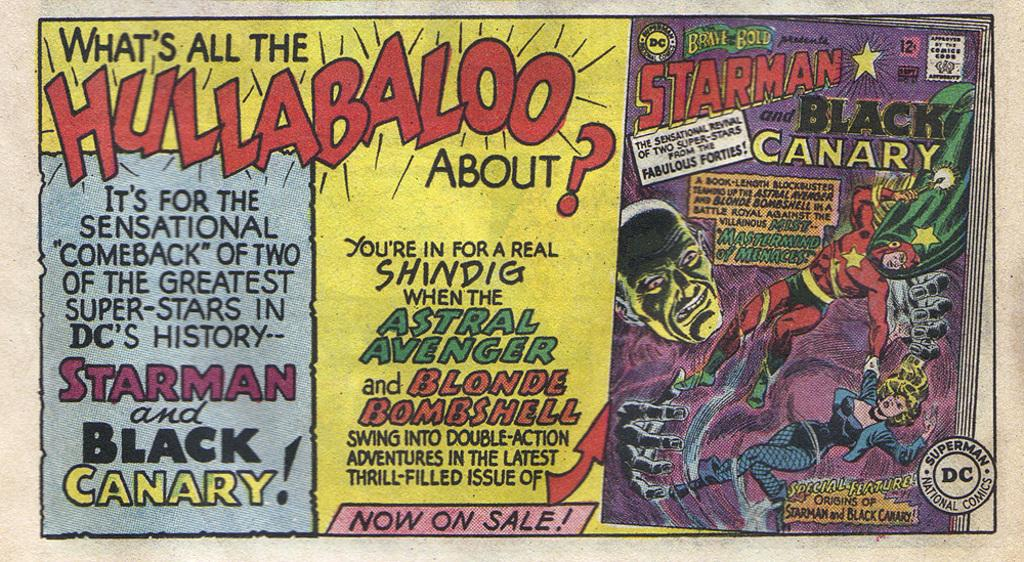<image>
Create a compact narrative representing the image presented. A comic book called Starman and the Black Canary is shown next to a headline about hullabaloo. 